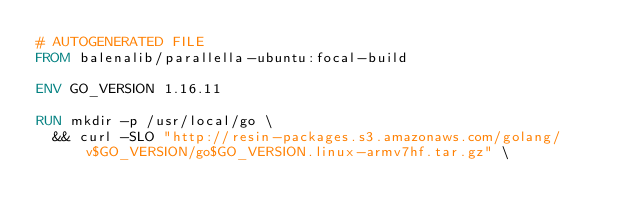<code> <loc_0><loc_0><loc_500><loc_500><_Dockerfile_># AUTOGENERATED FILE
FROM balenalib/parallella-ubuntu:focal-build

ENV GO_VERSION 1.16.11

RUN mkdir -p /usr/local/go \
	&& curl -SLO "http://resin-packages.s3.amazonaws.com/golang/v$GO_VERSION/go$GO_VERSION.linux-armv7hf.tar.gz" \</code> 